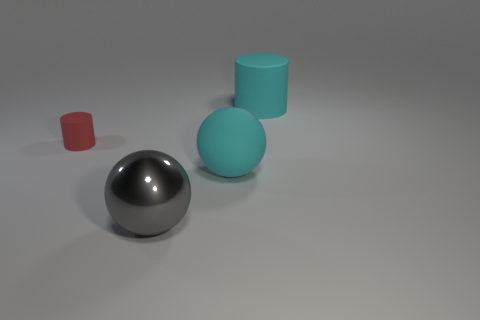There is a big object that is the same color as the large rubber ball; what material is it?
Your answer should be compact. Rubber. Is the material of the large cyan object to the left of the large matte cylinder the same as the large ball in front of the large cyan sphere?
Ensure brevity in your answer.  No. Do the rubber sphere and the big cylinder have the same color?
Give a very brief answer. Yes. There is another tiny cylinder that is made of the same material as the cyan cylinder; what color is it?
Offer a very short reply. Red. What number of other large spheres are the same material as the big gray sphere?
Your response must be concise. 0. Do the large rubber thing that is left of the big cyan matte cylinder and the large rubber cylinder have the same color?
Keep it short and to the point. Yes. What number of big cyan matte objects are the same shape as the small red rubber object?
Your answer should be compact. 1. Are there an equal number of tiny red things that are in front of the big gray thing and tiny red shiny cylinders?
Make the answer very short. Yes. There is a metallic ball that is the same size as the cyan cylinder; what color is it?
Provide a short and direct response. Gray. Is there a big green thing of the same shape as the big gray metal object?
Your answer should be very brief. No. 